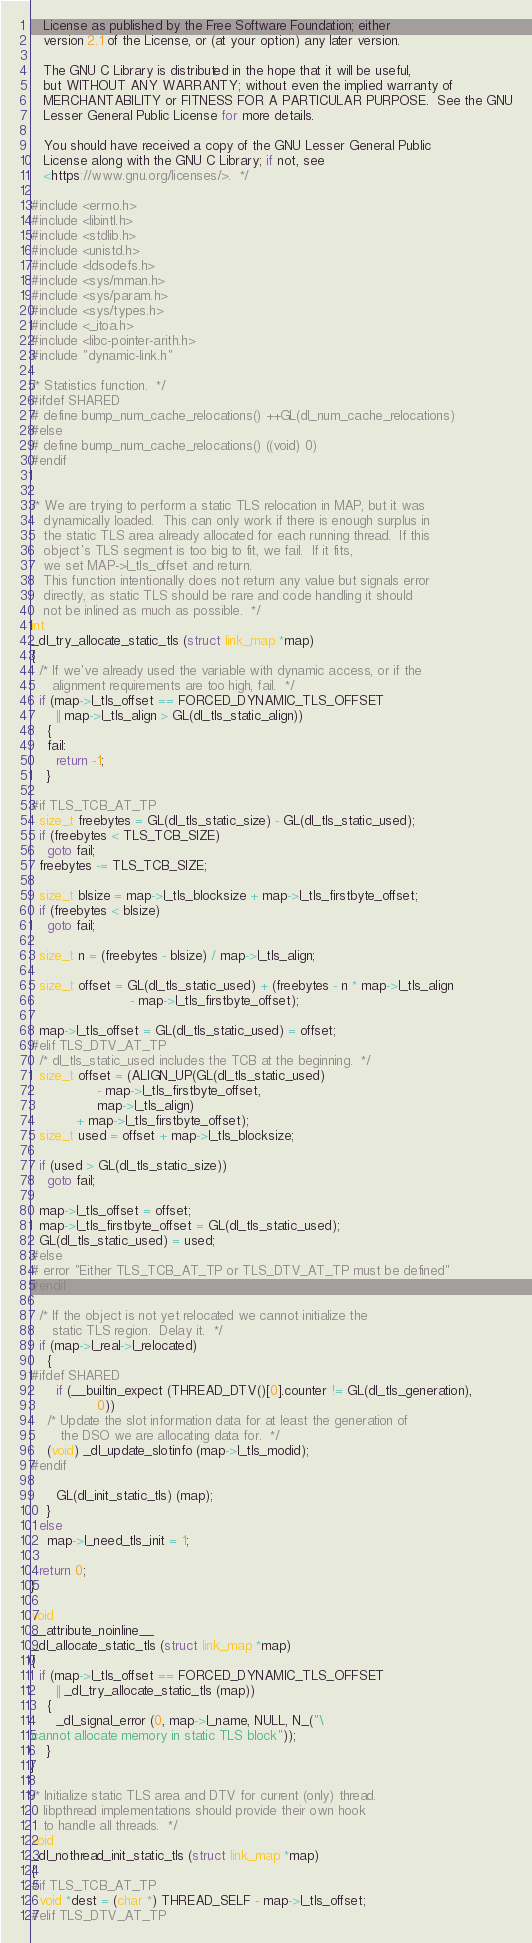Convert code to text. <code><loc_0><loc_0><loc_500><loc_500><_C_>   License as published by the Free Software Foundation; either
   version 2.1 of the License, or (at your option) any later version.

   The GNU C Library is distributed in the hope that it will be useful,
   but WITHOUT ANY WARRANTY; without even the implied warranty of
   MERCHANTABILITY or FITNESS FOR A PARTICULAR PURPOSE.  See the GNU
   Lesser General Public License for more details.

   You should have received a copy of the GNU Lesser General Public
   License along with the GNU C Library; if not, see
   <https://www.gnu.org/licenses/>.  */

#include <errno.h>
#include <libintl.h>
#include <stdlib.h>
#include <unistd.h>
#include <ldsodefs.h>
#include <sys/mman.h>
#include <sys/param.h>
#include <sys/types.h>
#include <_itoa.h>
#include <libc-pointer-arith.h>
#include "dynamic-link.h"

/* Statistics function.  */
#ifdef SHARED
# define bump_num_cache_relocations() ++GL(dl_num_cache_relocations)
#else
# define bump_num_cache_relocations() ((void) 0)
#endif


/* We are trying to perform a static TLS relocation in MAP, but it was
   dynamically loaded.  This can only work if there is enough surplus in
   the static TLS area already allocated for each running thread.  If this
   object's TLS segment is too big to fit, we fail.  If it fits,
   we set MAP->l_tls_offset and return.
   This function intentionally does not return any value but signals error
   directly, as static TLS should be rare and code handling it should
   not be inlined as much as possible.  */
int
_dl_try_allocate_static_tls (struct link_map *map)
{
  /* If we've already used the variable with dynamic access, or if the
     alignment requirements are too high, fail.  */
  if (map->l_tls_offset == FORCED_DYNAMIC_TLS_OFFSET
      || map->l_tls_align > GL(dl_tls_static_align))
    {
    fail:
      return -1;
    }

#if TLS_TCB_AT_TP
  size_t freebytes = GL(dl_tls_static_size) - GL(dl_tls_static_used);
  if (freebytes < TLS_TCB_SIZE)
    goto fail;
  freebytes -= TLS_TCB_SIZE;

  size_t blsize = map->l_tls_blocksize + map->l_tls_firstbyte_offset;
  if (freebytes < blsize)
    goto fail;

  size_t n = (freebytes - blsize) / map->l_tls_align;

  size_t offset = GL(dl_tls_static_used) + (freebytes - n * map->l_tls_align
					    - map->l_tls_firstbyte_offset);

  map->l_tls_offset = GL(dl_tls_static_used) = offset;
#elif TLS_DTV_AT_TP
  /* dl_tls_static_used includes the TCB at the beginning.  */
  size_t offset = (ALIGN_UP(GL(dl_tls_static_used)
			    - map->l_tls_firstbyte_offset,
			    map->l_tls_align)
		   + map->l_tls_firstbyte_offset);
  size_t used = offset + map->l_tls_blocksize;

  if (used > GL(dl_tls_static_size))
    goto fail;

  map->l_tls_offset = offset;
  map->l_tls_firstbyte_offset = GL(dl_tls_static_used);
  GL(dl_tls_static_used) = used;
#else
# error "Either TLS_TCB_AT_TP or TLS_DTV_AT_TP must be defined"
#endif

  /* If the object is not yet relocated we cannot initialize the
     static TLS region.  Delay it.  */
  if (map->l_real->l_relocated)
    {
#ifdef SHARED
      if (__builtin_expect (THREAD_DTV()[0].counter != GL(dl_tls_generation),
			    0))
	/* Update the slot information data for at least the generation of
	   the DSO we are allocating data for.  */
	(void) _dl_update_slotinfo (map->l_tls_modid);
#endif

      GL(dl_init_static_tls) (map);
    }
  else
    map->l_need_tls_init = 1;

  return 0;
}

void
__attribute_noinline__
_dl_allocate_static_tls (struct link_map *map)
{
  if (map->l_tls_offset == FORCED_DYNAMIC_TLS_OFFSET
      || _dl_try_allocate_static_tls (map))
    {
      _dl_signal_error (0, map->l_name, NULL, N_("\
cannot allocate memory in static TLS block"));
    }
}

/* Initialize static TLS area and DTV for current (only) thread.
   libpthread implementations should provide their own hook
   to handle all threads.  */
void
_dl_nothread_init_static_tls (struct link_map *map)
{
#if TLS_TCB_AT_TP
  void *dest = (char *) THREAD_SELF - map->l_tls_offset;
#elif TLS_DTV_AT_TP</code> 